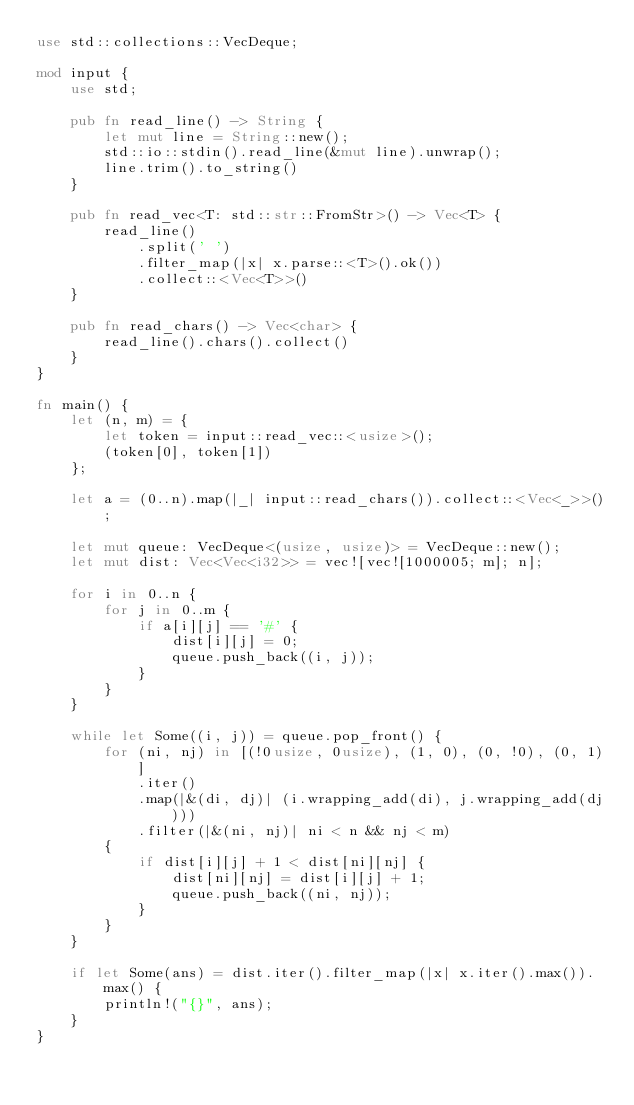<code> <loc_0><loc_0><loc_500><loc_500><_Rust_>use std::collections::VecDeque;

mod input {
    use std;

    pub fn read_line() -> String {
        let mut line = String::new();
        std::io::stdin().read_line(&mut line).unwrap();
        line.trim().to_string()
    }

    pub fn read_vec<T: std::str::FromStr>() -> Vec<T> {
        read_line()
            .split(' ')
            .filter_map(|x| x.parse::<T>().ok())
            .collect::<Vec<T>>()
    }

    pub fn read_chars() -> Vec<char> {
        read_line().chars().collect()
    }
}

fn main() {
    let (n, m) = {
        let token = input::read_vec::<usize>();
        (token[0], token[1])
    };

    let a = (0..n).map(|_| input::read_chars()).collect::<Vec<_>>();

    let mut queue: VecDeque<(usize, usize)> = VecDeque::new();
    let mut dist: Vec<Vec<i32>> = vec![vec![1000005; m]; n];

    for i in 0..n {
        for j in 0..m {
            if a[i][j] == '#' {
                dist[i][j] = 0;
                queue.push_back((i, j));
            }
        }
    }

    while let Some((i, j)) = queue.pop_front() {
        for (ni, nj) in [(!0usize, 0usize), (1, 0), (0, !0), (0, 1)]
            .iter()
            .map(|&(di, dj)| (i.wrapping_add(di), j.wrapping_add(dj)))
            .filter(|&(ni, nj)| ni < n && nj < m)
        {
            if dist[i][j] + 1 < dist[ni][nj] {
                dist[ni][nj] = dist[i][j] + 1;
                queue.push_back((ni, nj));
            }
        }
    }

    if let Some(ans) = dist.iter().filter_map(|x| x.iter().max()).max() {
        println!("{}", ans);
    }
}
</code> 